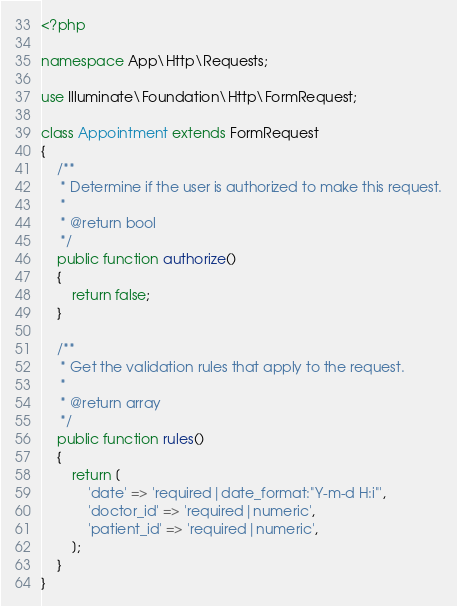<code> <loc_0><loc_0><loc_500><loc_500><_PHP_><?php

namespace App\Http\Requests;

use Illuminate\Foundation\Http\FormRequest;

class Appointment extends FormRequest
{
    /**
     * Determine if the user is authorized to make this request.
     *
     * @return bool
     */
    public function authorize()
    {
        return false;
    }

    /**
     * Get the validation rules that apply to the request.
     *
     * @return array
     */
    public function rules()
    {
        return [
            'date' => 'required|date_format:"Y-m-d H:i"',
            'doctor_id' => 'required|numeric',
            'patient_id' => 'required|numeric',
        ];
    }
}
</code> 